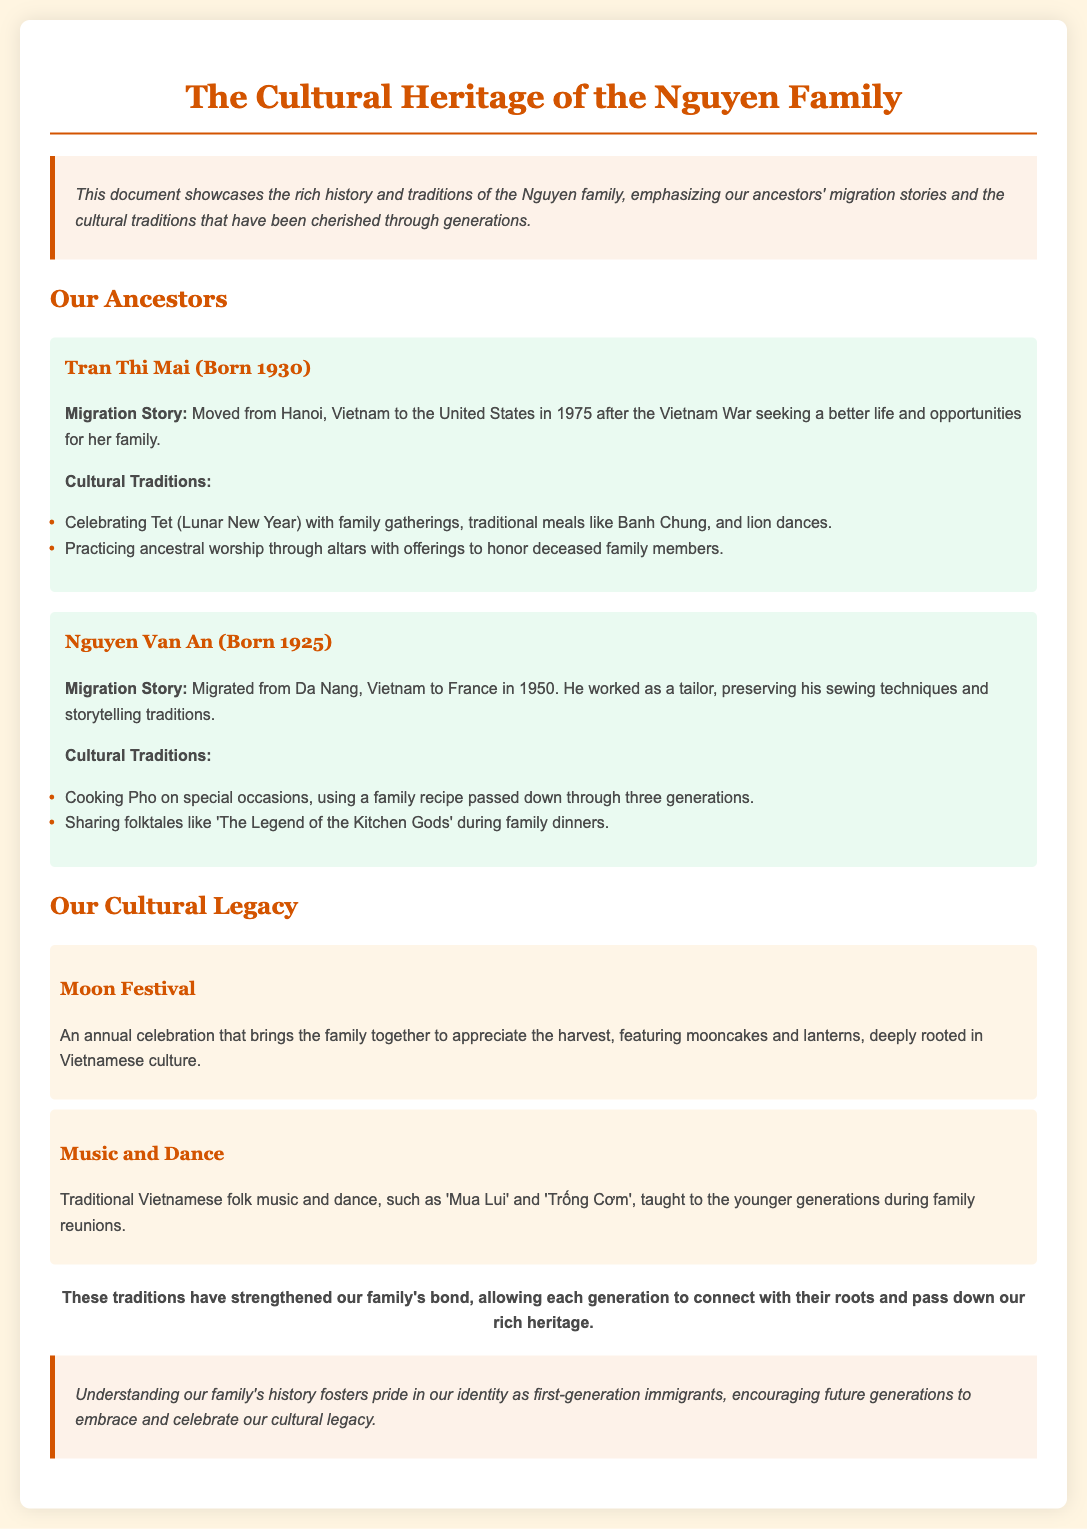What is the title of the document? The title of the document is prominently displayed at the top, introducing the family heritage.
Answer: The Cultural Heritage of the Nguyen Family Who migrated from Hanoi in 1975? The document details the migration story of a specific ancestor and their year of migration.
Answer: Tran Thi Mai What is the birth year of Nguyen Van An? The document mentions the birth year of this ancestor under their name.
Answer: 1925 What traditional food is mentioned for special occasions? A cultural tradition related to food is described in one of the ancestor's stories.
Answer: Pho What festival is celebrated annually in the family? The document highlights a specific cultural festival celebrated within the family.
Answer: Moon Festival Which ancestor preserved sewing techniques? The migration story includes information on the skills and techniques preserved by one ancestor.
Answer: Nguyen Van An How many generations has the family recipe for Pho been passed down? The document indicates the number of generations related to the family recipe.
Answer: Three generations What kind of music and dance is taught to younger generations? The document describes types of music and dance that are an integral part of the cultural legacy.
Answer: Traditional Vietnamese folk music and dance 